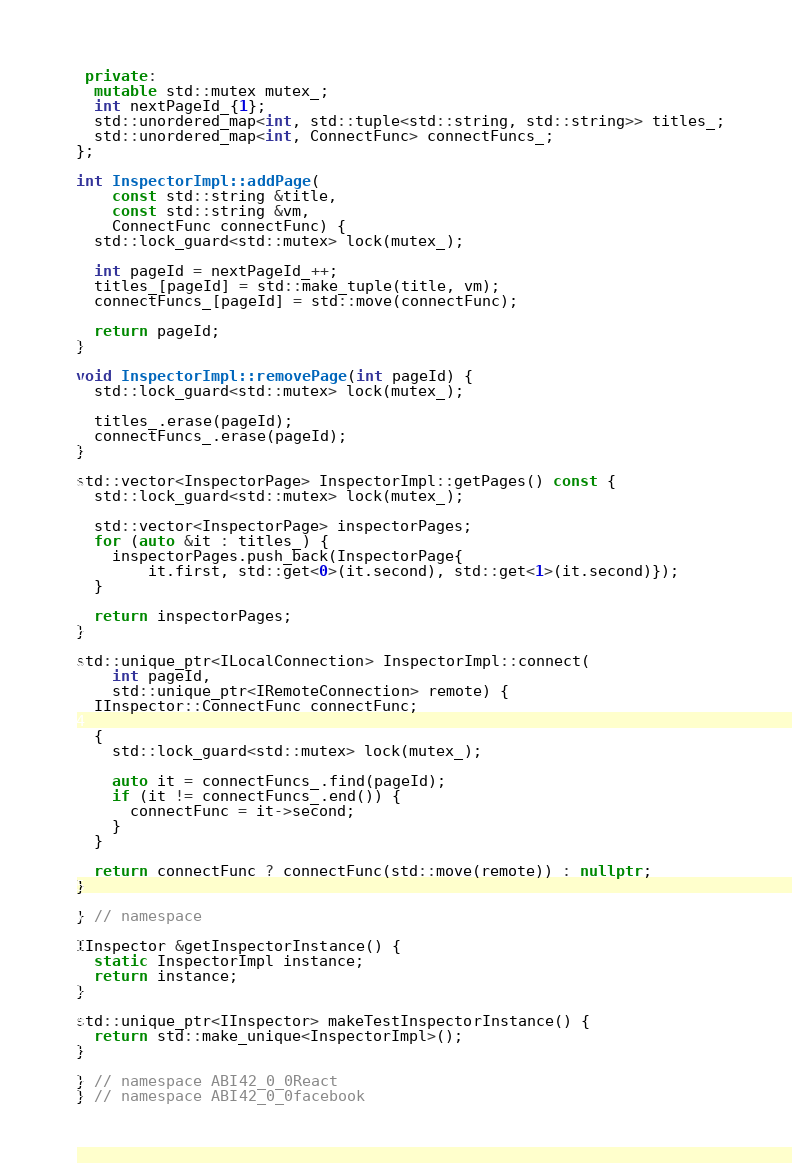<code> <loc_0><loc_0><loc_500><loc_500><_C++_>
 private:
  mutable std::mutex mutex_;
  int nextPageId_{1};
  std::unordered_map<int, std::tuple<std::string, std::string>> titles_;
  std::unordered_map<int, ConnectFunc> connectFuncs_;
};

int InspectorImpl::addPage(
    const std::string &title,
    const std::string &vm,
    ConnectFunc connectFunc) {
  std::lock_guard<std::mutex> lock(mutex_);

  int pageId = nextPageId_++;
  titles_[pageId] = std::make_tuple(title, vm);
  connectFuncs_[pageId] = std::move(connectFunc);

  return pageId;
}

void InspectorImpl::removePage(int pageId) {
  std::lock_guard<std::mutex> lock(mutex_);

  titles_.erase(pageId);
  connectFuncs_.erase(pageId);
}

std::vector<InspectorPage> InspectorImpl::getPages() const {
  std::lock_guard<std::mutex> lock(mutex_);

  std::vector<InspectorPage> inspectorPages;
  for (auto &it : titles_) {
    inspectorPages.push_back(InspectorPage{
        it.first, std::get<0>(it.second), std::get<1>(it.second)});
  }

  return inspectorPages;
}

std::unique_ptr<ILocalConnection> InspectorImpl::connect(
    int pageId,
    std::unique_ptr<IRemoteConnection> remote) {
  IInspector::ConnectFunc connectFunc;

  {
    std::lock_guard<std::mutex> lock(mutex_);

    auto it = connectFuncs_.find(pageId);
    if (it != connectFuncs_.end()) {
      connectFunc = it->second;
    }
  }

  return connectFunc ? connectFunc(std::move(remote)) : nullptr;
}

} // namespace

IInspector &getInspectorInstance() {
  static InspectorImpl instance;
  return instance;
}

std::unique_ptr<IInspector> makeTestInspectorInstance() {
  return std::make_unique<InspectorImpl>();
}

} // namespace ABI42_0_0React
} // namespace ABI42_0_0facebook
</code> 